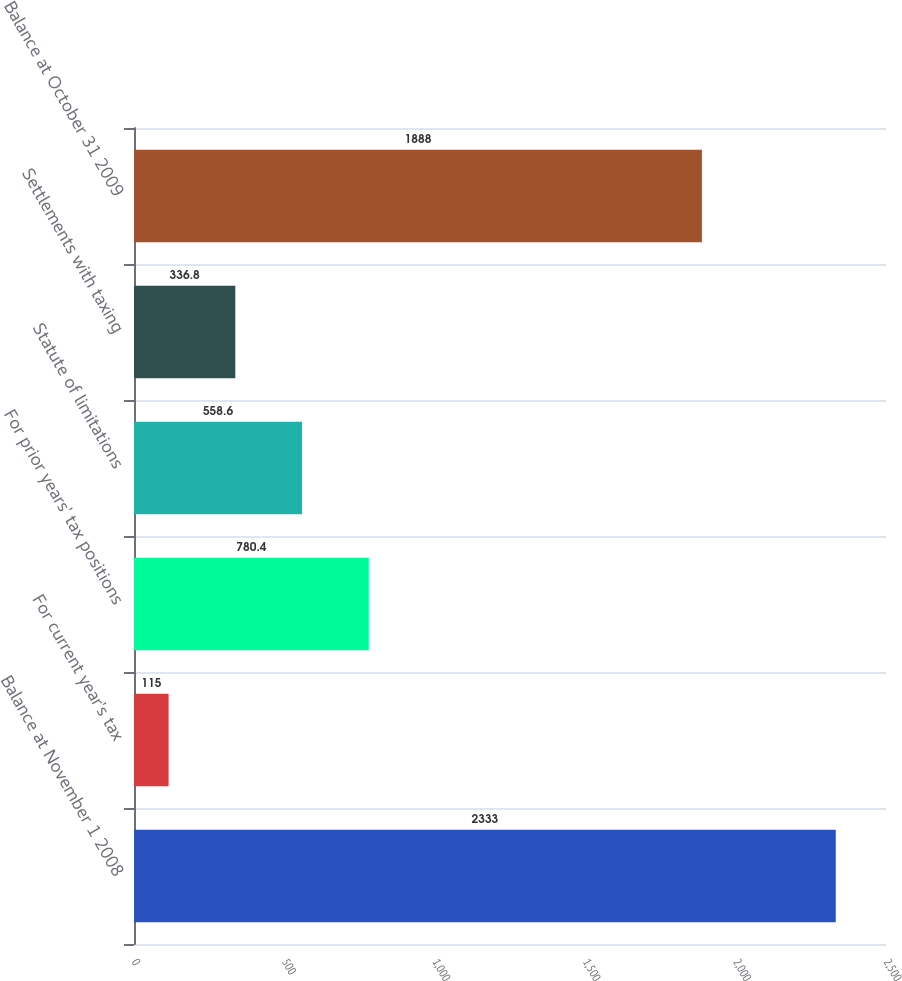Convert chart to OTSL. <chart><loc_0><loc_0><loc_500><loc_500><bar_chart><fcel>Balance at November 1 2008<fcel>For current year's tax<fcel>For prior years' tax positions<fcel>Statute of limitations<fcel>Settlements with taxing<fcel>Balance at October 31 2009<nl><fcel>2333<fcel>115<fcel>780.4<fcel>558.6<fcel>336.8<fcel>1888<nl></chart> 